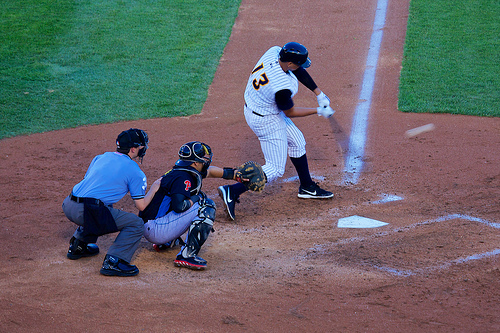Who wears a shirt? The umpire wears a shirt, distinct in its blue color, which makes him easily noticeable on the field. 